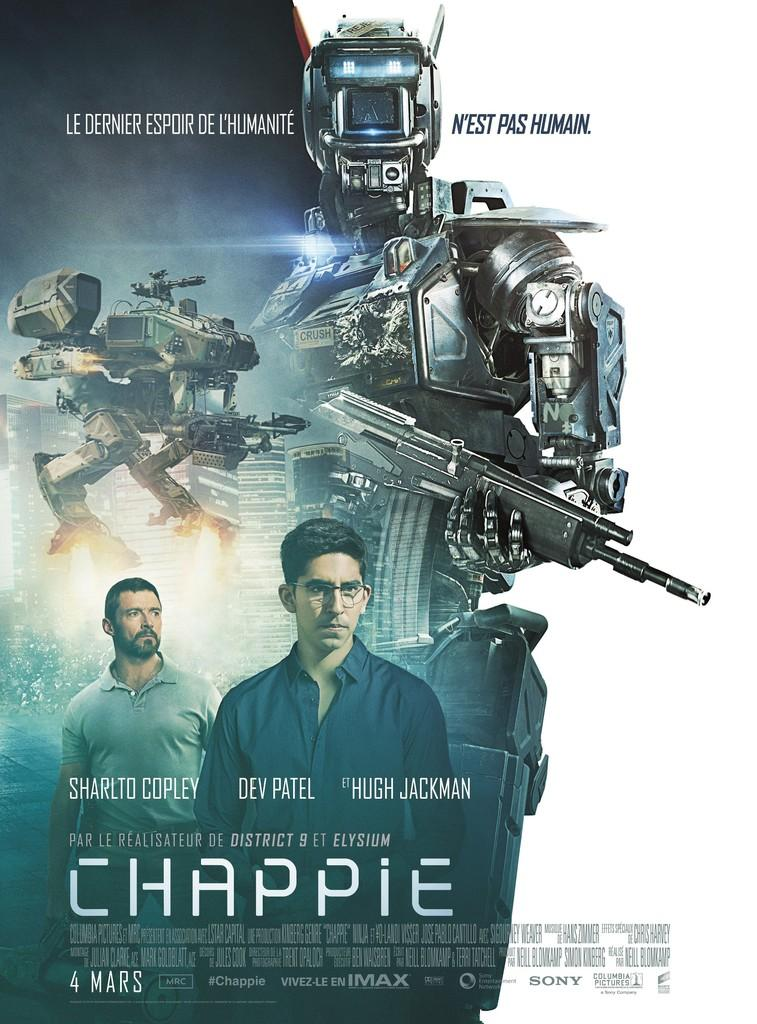<image>
Offer a succinct explanation of the picture presented. The cover to a movie called Chappie starring Hugh Jackman. 